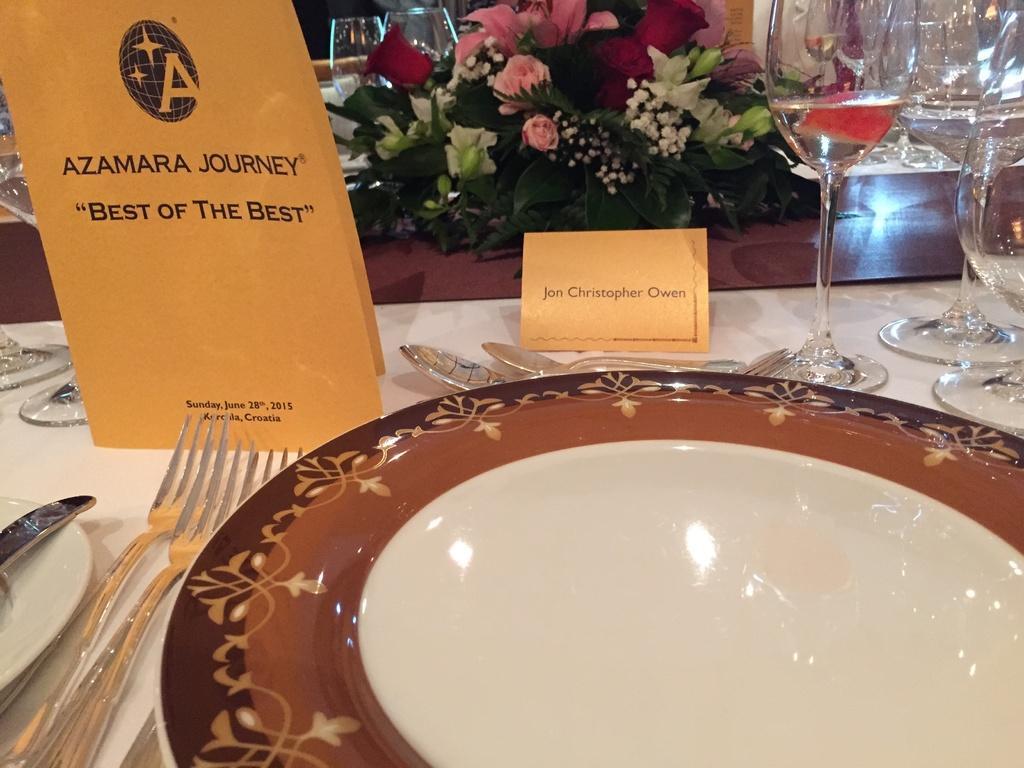Could you give a brief overview of what you see in this image? In this picture, it looks like a table and on the table there are plates, forks, spoons, knife, cards, drinking glasses and a flower vase. 